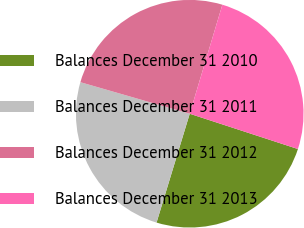<chart> <loc_0><loc_0><loc_500><loc_500><pie_chart><fcel>Balances December 31 2010<fcel>Balances December 31 2011<fcel>Balances December 31 2012<fcel>Balances December 31 2013<nl><fcel>24.69%<fcel>24.76%<fcel>25.16%<fcel>25.39%<nl></chart> 